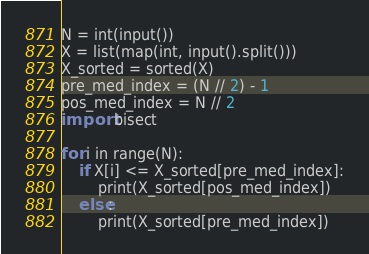Convert code to text. <code><loc_0><loc_0><loc_500><loc_500><_Python_>N = int(input())
X = list(map(int, input().split()))
X_sorted = sorted(X)
pre_med_index = (N // 2) - 1
pos_med_index = N // 2
import bisect

for i in range(N):
    if X[i] <= X_sorted[pre_med_index]:
        print(X_sorted[pos_med_index])
    else:
        print(X_sorted[pre_med_index])
</code> 